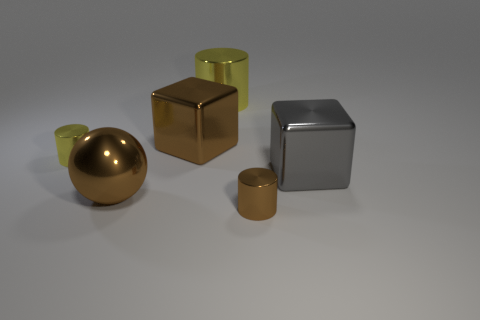Subtract all large cylinders. How many cylinders are left? 2 Subtract all blue spheres. How many yellow cylinders are left? 2 Add 3 small metal objects. How many objects exist? 9 Subtract all purple cylinders. Subtract all red balls. How many cylinders are left? 3 Subtract all balls. How many objects are left? 5 Subtract all small brown things. Subtract all large things. How many objects are left? 1 Add 6 gray blocks. How many gray blocks are left? 7 Add 1 small metallic things. How many small metallic things exist? 3 Subtract 0 cyan cylinders. How many objects are left? 6 